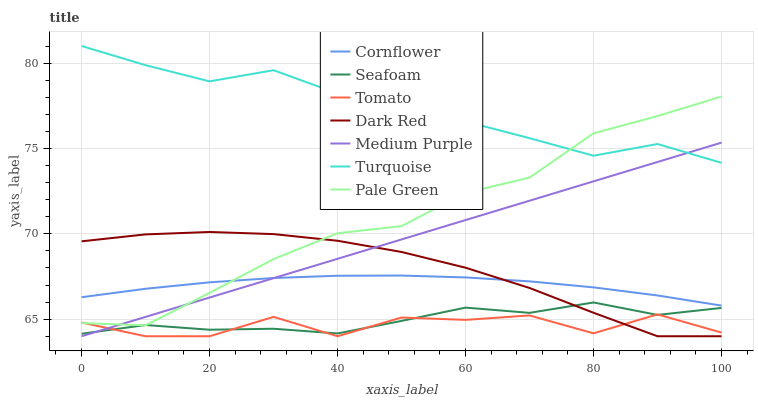Does Tomato have the minimum area under the curve?
Answer yes or no. Yes. Does Turquoise have the maximum area under the curve?
Answer yes or no. Yes. Does Cornflower have the minimum area under the curve?
Answer yes or no. No. Does Cornflower have the maximum area under the curve?
Answer yes or no. No. Is Medium Purple the smoothest?
Answer yes or no. Yes. Is Tomato the roughest?
Answer yes or no. Yes. Is Cornflower the smoothest?
Answer yes or no. No. Is Cornflower the roughest?
Answer yes or no. No. Does Tomato have the lowest value?
Answer yes or no. Yes. Does Cornflower have the lowest value?
Answer yes or no. No. Does Turquoise have the highest value?
Answer yes or no. Yes. Does Cornflower have the highest value?
Answer yes or no. No. Is Seafoam less than Turquoise?
Answer yes or no. Yes. Is Cornflower greater than Seafoam?
Answer yes or no. Yes. Does Tomato intersect Dark Red?
Answer yes or no. Yes. Is Tomato less than Dark Red?
Answer yes or no. No. Is Tomato greater than Dark Red?
Answer yes or no. No. Does Seafoam intersect Turquoise?
Answer yes or no. No. 